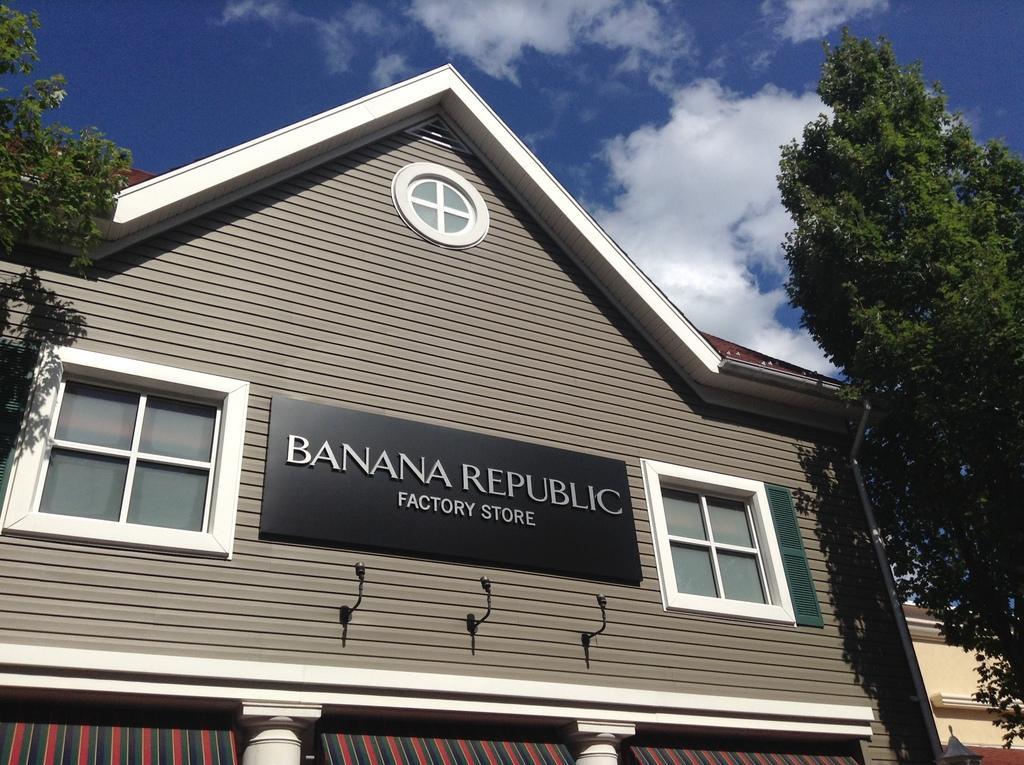Can you describe this image briefly? In this picture, there is a building with a board and windows. On the board, there is some text. Towards the left and right, there are trees. On the top, there is a sky with clouds. 